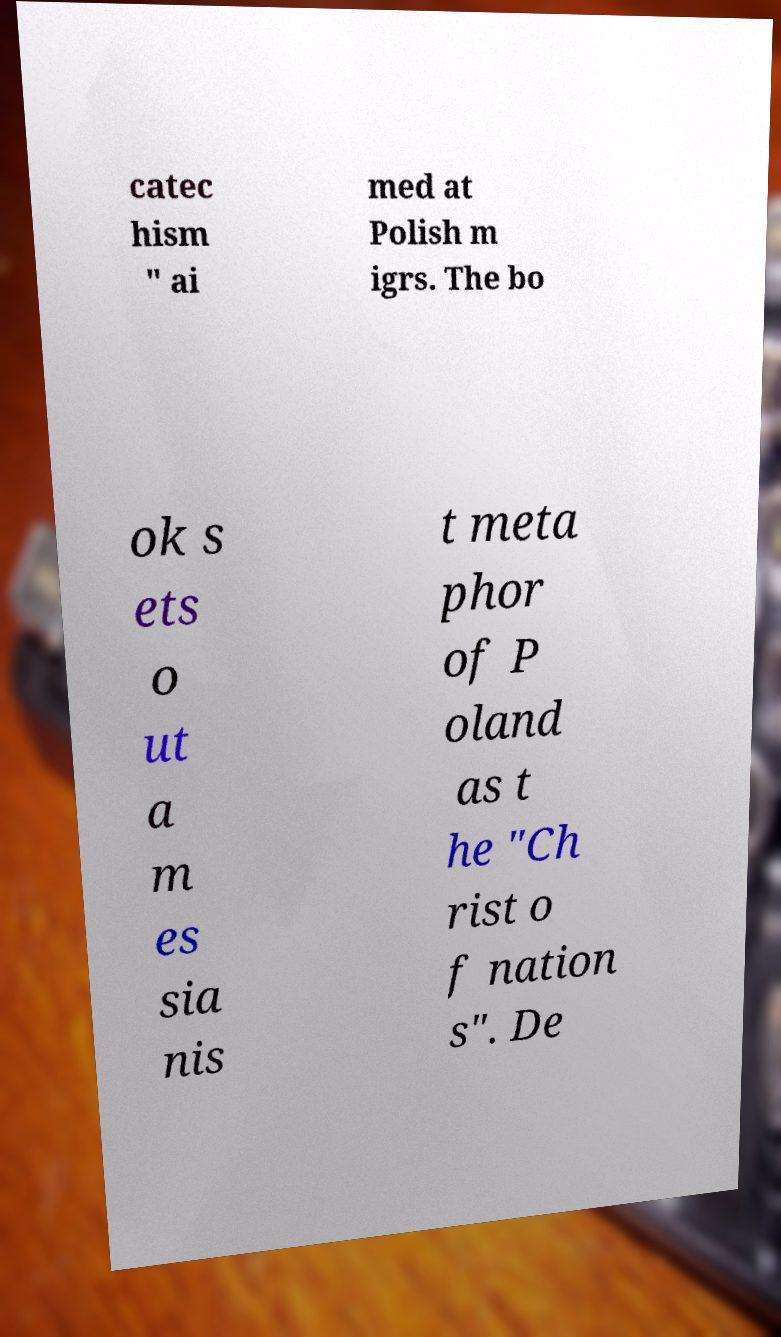Please identify and transcribe the text found in this image. catec hism " ai med at Polish m igrs. The bo ok s ets o ut a m es sia nis t meta phor of P oland as t he "Ch rist o f nation s". De 